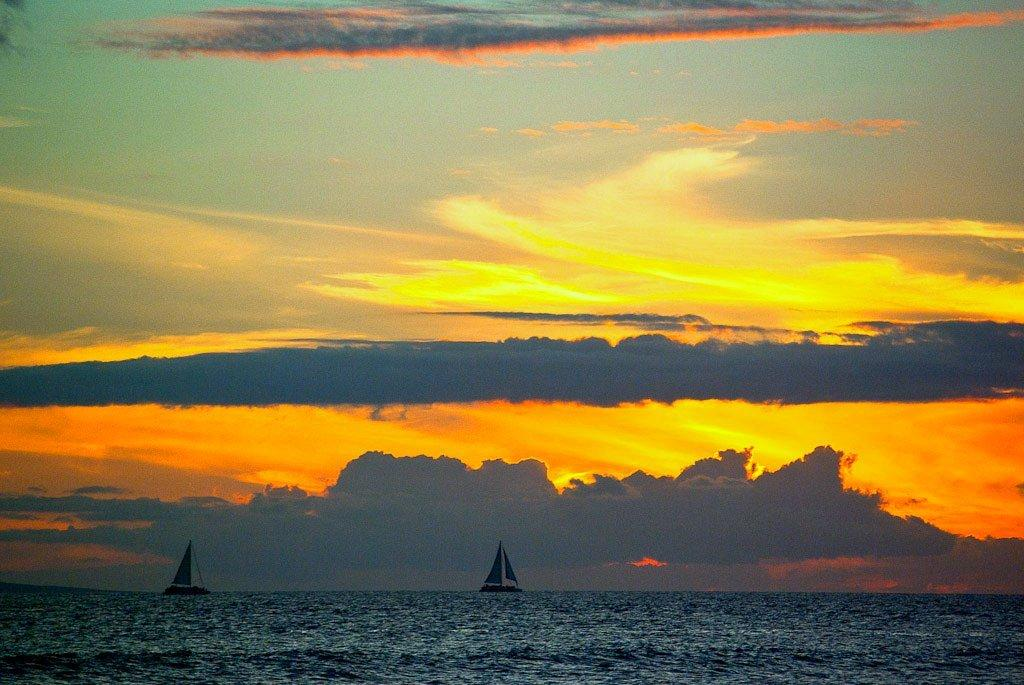How many boats can be seen in the image? There are two boats in the image. What are the boats doing in the image? The boats are traveling. What is visible at the bottom of the image? There is water visible at the bottom of the image. What part of the boats is visible in the image? The sails of the boats are visible. How would you describe the sky in the background of the image? The sky in the background is cloudy. Can you tell me how many ducks are swimming near the boats in the image? There are no ducks present in the image; it only features two boats. What type of design is visible on the sails of the boats? The provided facts do not mention any specific design on the sails of the boats. 